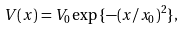Convert formula to latex. <formula><loc_0><loc_0><loc_500><loc_500>V ( x ) = V _ { 0 } \exp { \{ - ( x / x _ { 0 } ) ^ { 2 } \} } ,</formula> 